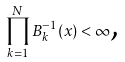Convert formula to latex. <formula><loc_0><loc_0><loc_500><loc_500>\prod _ { k = 1 } ^ { N } B _ { k } ^ { - 1 } ( x ) < \infty \text {,}</formula> 